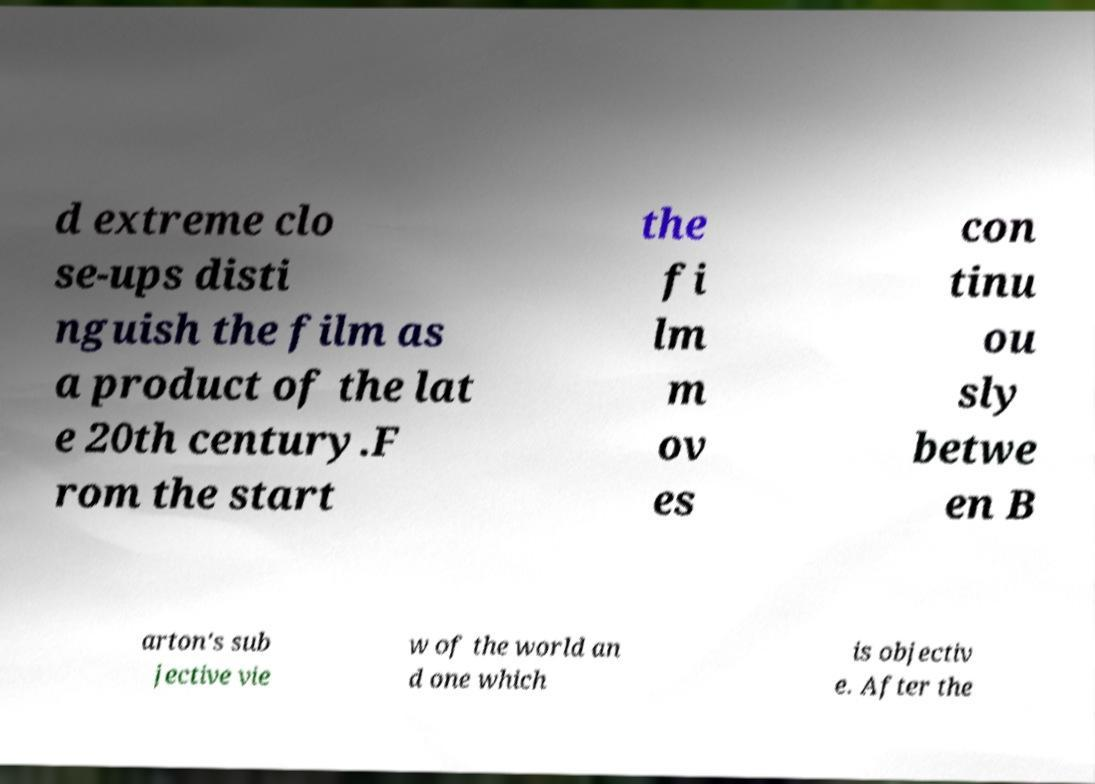There's text embedded in this image that I need extracted. Can you transcribe it verbatim? d extreme clo se-ups disti nguish the film as a product of the lat e 20th century.F rom the start the fi lm m ov es con tinu ou sly betwe en B arton's sub jective vie w of the world an d one which is objectiv e. After the 